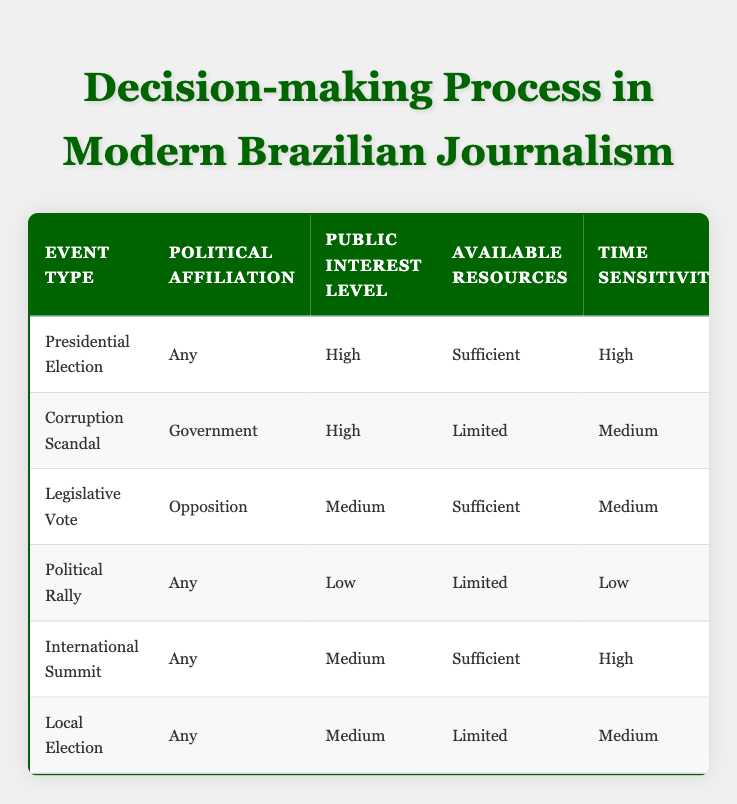What actions are planned for covering a Presidential Election? The row for the Presidential Election indicates that all listed actions are planned: a senior reporter will be assigned, an in-depth investigation will be conducted, expert commentary will be sought, live coverage will occur, social media will be engaged, and an editorial will be published.
Answer: Yes to all actions Is live coverage being done for all high-public-interest events? The table shows that live coverage is not planned for the Corruption Scandal despite it having a high public interest level. Therefore, live coverage is not done for all high-public-interest events.
Answer: No What is the political affiliation for the Legislative Vote event? Referring to the row for Legislative Vote, the listed political affiliation is Opposition.
Answer: Opposition How many actions are planned for events with sufficient available resources? There are three events listed with sufficient resources: Presidential Election, Legislative Vote, and International Summit. The total actions planned for those events are: 6 (Presidential Election) + 5 (Legislative Vote) + 5 (International Summit) = 16 actions.
Answer: 16 actions Is a senior reporter assigned for the Local Election event? According to the row for Local Election, a senior reporter is not assigned as indicated by "No."
Answer: No Which event has the second highest public interest level? The Corruption Scandal has the highest public interest level of high, while the next level down is medium. The events sharing medium public interest are Legislative Vote, International Summit, and Local Election. The Corruption Scandal is the highest, so the second highest public interest level belongs to these medium-level events.
Answer: Legislative Vote, International Summit, Local Election How many events require social media coverage? Referring to the actions across all events, the table indicates that social media coverage is required for every event except the Political Rally and Local Election, making it a total of 4 events requiring social media coverage.
Answer: 4 events Are expert comments considered for covering a Corruption Scandal? The table specifies that expert commentary is sought for the Corruption Scandal, as stated in the corresponding row where it says "Yes."
Answer: Yes 